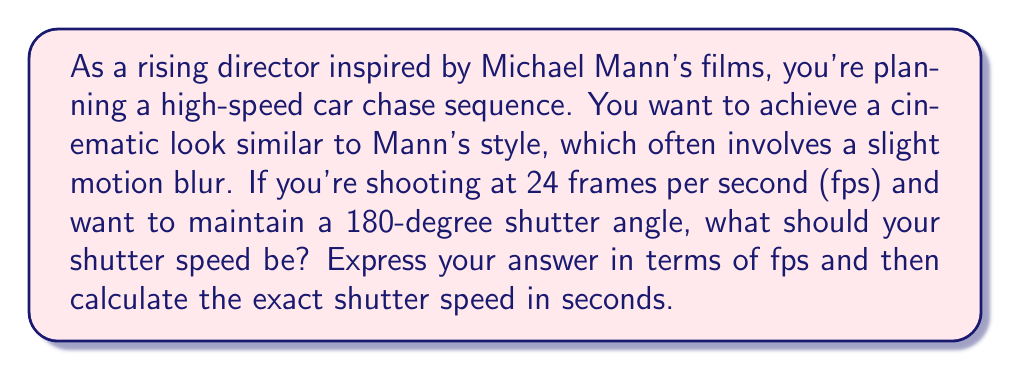What is the answer to this math problem? To solve this problem, we need to understand the relationship between frame rate, shutter angle, and shutter speed:

1) The shutter angle is the portion of the frame duration during which the shutter is open. A 180-degree shutter angle means the shutter is open for half of each frame's duration.

2) The relationship between frame rate (fps), shutter angle (θ), and shutter speed (s) is given by the formula:

   $$s = \frac{1}{fps} \cdot \frac{\theta}{360°}$$

3) In this case, we have:
   - fps = 24
   - θ = 180°

4) Substituting these values into our formula:

   $$s = \frac{1}{24} \cdot \frac{180°}{360°} = \frac{1}{24} \cdot \frac{1}{2}$$

5) Simplifying:

   $$s = \frac{1}{48}$$

6) To express this in terms of fps:

   $$s = \frac{1}{2 \cdot fps}$$

7) To calculate the exact shutter speed in seconds:

   $$s = \frac{1}{48} = 0.0208333... \text{ seconds}$$

This is approximately 1/48th of a second, which is a common shutter speed in filmmaking when shooting at 24 fps with a 180-degree shutter angle.
Answer: The shutter speed should be $\frac{1}{2 \cdot fps}$ or $\frac{1}{48}$ seconds (approximately 0.0208333 seconds). 